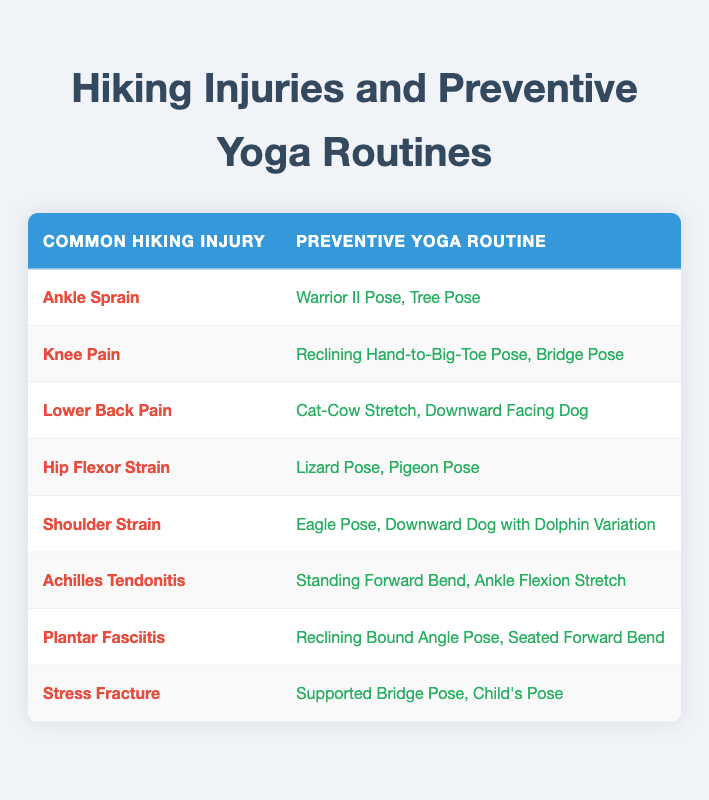What preventive yoga routine can help with Ankle Sprains? The table lists "Warrior II Pose, Tree Pose" as the preventive yoga routine for Ankle Sprains.
Answer: Warrior II Pose, Tree Pose Which injury has "Reclining Bound Angle Pose" as part of its preventive routine? According to the table, "Reclining Bound Angle Pose" is paired with "Plantar Fasciitis."
Answer: Plantar Fasciitis Is "Cat-Cow Stretch" recommended for both Lower Back Pain and Hip Flexor Strain? The table shows "Cat-Cow Stretch" is only listed for Lower Back Pain and not for Hip Flexor Strain, so it is not recommended for both.
Answer: No Which injuries are addressed by the routine "Eagle Pose, Downward Dog with Dolphin Variation"? This routine is specifically linked to "Shoulder Strain" as shown in the table. It does not address any other injuries.
Answer: Shoulder Strain How many different yoga poses are suggested for knee-related issues? The table suggests "Reclining Hand-to-Big-Toe Pose, Bridge Pose" for Knee Pain, totaling 2 different poses targeted towards knee-related issues.
Answer: 2 If a hiker experiences both Ankle Sprain and Lower Back Pain, which yoga poses should they practice? The table lists "Warrior II Pose, Tree Pose" for Ankle Sprain and "Cat-Cow Stretch, Downward Facing Dog" for Lower Back Pain. Therefore, they should practice both sets of poses.
Answer: Warrior II Pose, Tree Pose; Cat-Cow Stretch, Downward Facing Dog Are there any preventive yoga routines listed for Stress Fractures? Yes, the table states "Supported Bridge Pose, Child's Pose" as the preventive yoga routine for Stress Fractures.
Answer: Yes What is the total number of common hiking injuries listed in the table? The table contains entries for a total of 8 common hiking injuries, which can be seen by counting the rows under the injuries column.
Answer: 8 Which preventive yoga routine includes "Pigeon Pose"? The routine that includes "Pigeon Pose" is listed for "Hip Flexor Strain" in the table.
Answer: Hip Flexor Strain 